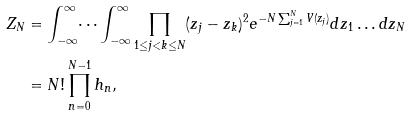<formula> <loc_0><loc_0><loc_500><loc_500>Z _ { N } & = \int _ { - \infty } ^ { \infty } \dots \int _ { - \infty } ^ { \infty } \prod _ { 1 \leq j < k \leq N } ( z _ { j } - z _ { k } ) ^ { 2 } e ^ { - N \sum _ { j = 1 } ^ { N } V ( z _ { j } ) } d z _ { 1 } \dots d z _ { N } \\ & = N ! \prod _ { n = 0 } ^ { N - 1 } h _ { n } ,</formula> 